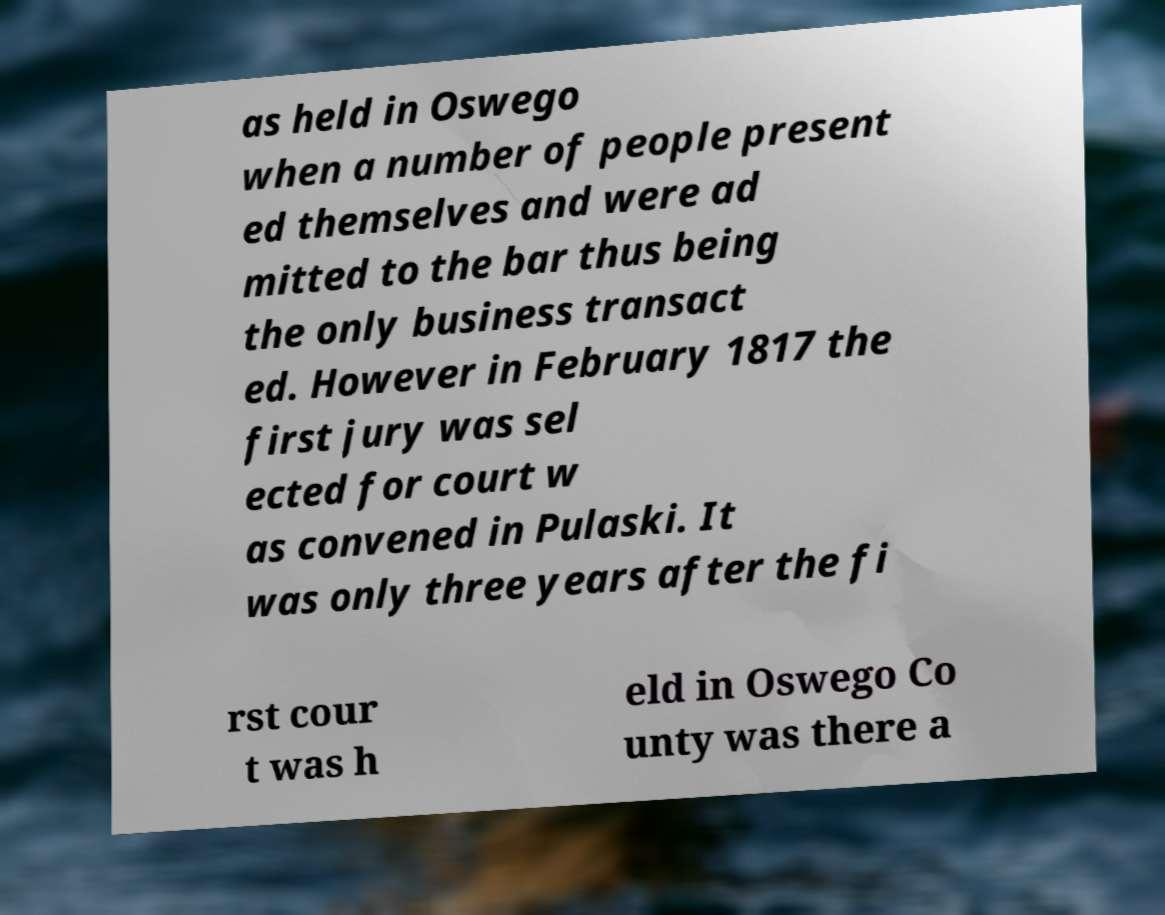Could you assist in decoding the text presented in this image and type it out clearly? as held in Oswego when a number of people present ed themselves and were ad mitted to the bar thus being the only business transact ed. However in February 1817 the first jury was sel ected for court w as convened in Pulaski. It was only three years after the fi rst cour t was h eld in Oswego Co unty was there a 